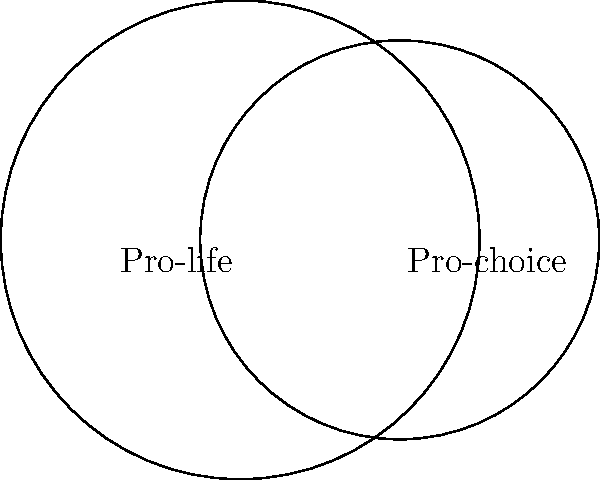In the coordinate system above, two circles represent pro-life and pro-choice arguments. The pro-life circle has a radius of 3 units and is centered at (-1, 0), while the pro-choice circle has a radius of 2.5 units and is centered at (1, 0). Calculate the area of overlap between these two circles, which represents the common ground between the two perspectives. Round your answer to two decimal places. To find the area of overlap between two circles, we can use the following steps:

1. Calculate the distance between the centers:
   $d = \sqrt{(x_2 - x_1)^2 + (y_2 - y_1)^2} = \sqrt{(1 - (-1))^2 + (0 - 0)^2} = 2$

2. Use the formula for the area of intersection:
   $A = r_1^2 \arccos(\frac{d^2 + r_1^2 - r_2^2}{2dr_1}) + r_2^2 \arccos(\frac{d^2 + r_2^2 - r_1^2}{2dr_2}) - \frac{1}{2}\sqrt{(-d+r_1+r_2)(d+r_1-r_2)(d-r_1+r_2)(d+r_1+r_2)}$

3. Substitute the values:
   $r_1 = 3, r_2 = 2.5, d = 2$

4. Calculate:
   $A = 3^2 \arccos(\frac{2^2 + 3^2 - 2.5^2}{2 \cdot 2 \cdot 3}) + 2.5^2 \arccos(\frac{2^2 + 2.5^2 - 3^2}{2 \cdot 2 \cdot 2.5}) - \frac{1}{2}\sqrt{(-2+3+2.5)(2+3-2.5)(2-3+2.5)(2+3+2.5)}$

5. Evaluate:
   $A \approx 5.0549$

6. Round to two decimal places:
   $A \approx 5.05$ square units
Answer: 5.05 square units 